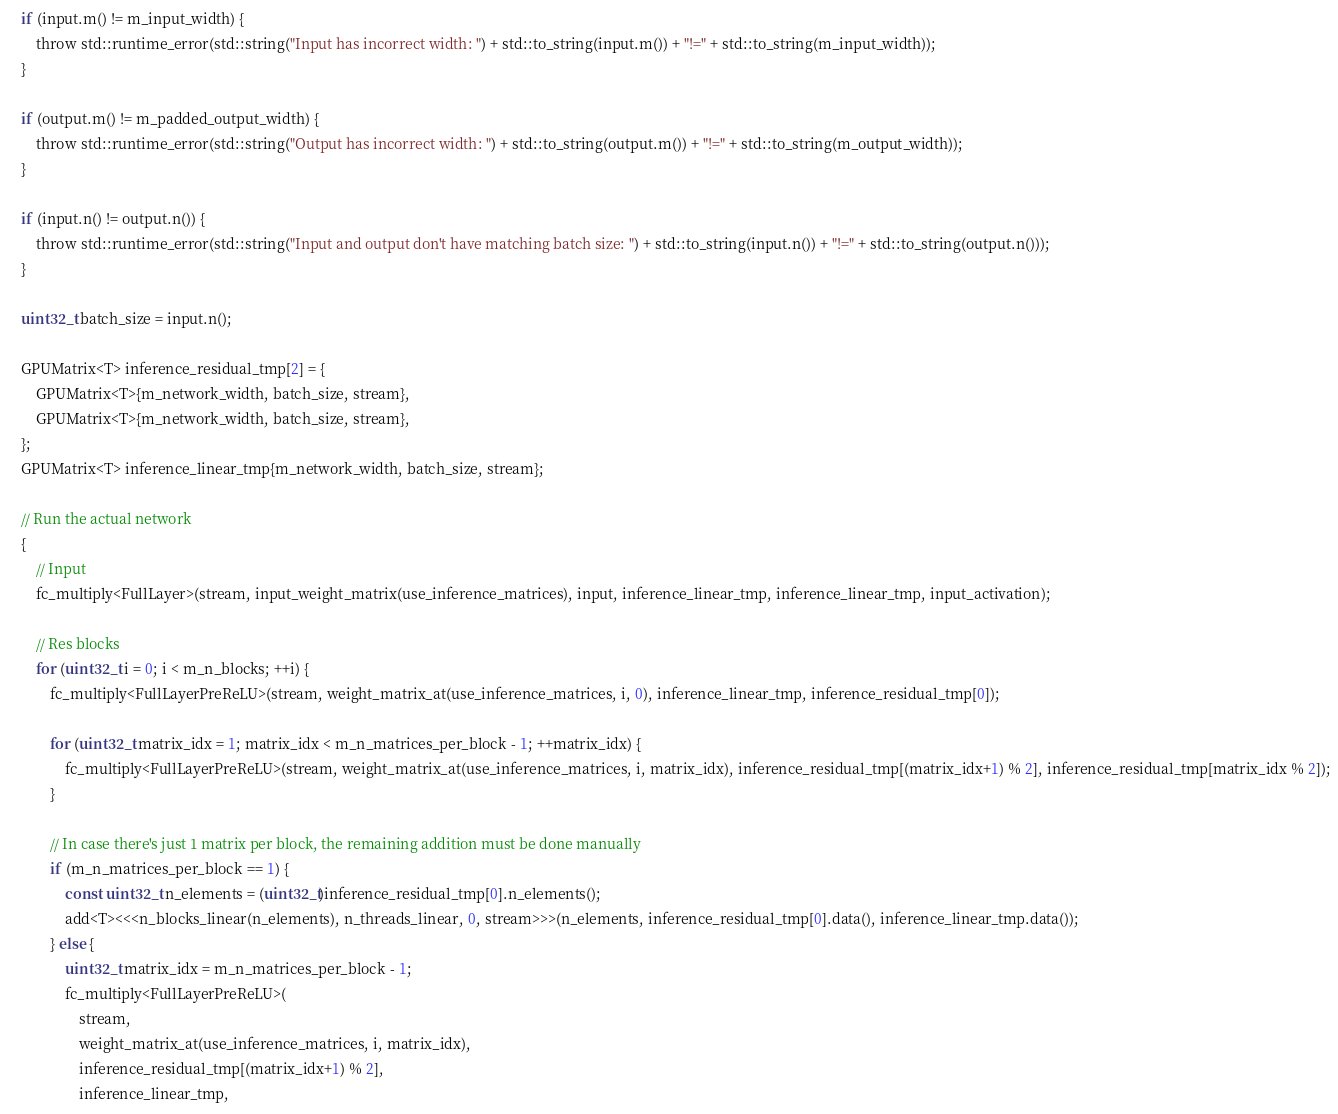Convert code to text. <code><loc_0><loc_0><loc_500><loc_500><_Cuda_>	if (input.m() != m_input_width) {
		throw std::runtime_error(std::string("Input has incorrect width: ") + std::to_string(input.m()) + "!=" + std::to_string(m_input_width));
	}

	if (output.m() != m_padded_output_width) {
		throw std::runtime_error(std::string("Output has incorrect width: ") + std::to_string(output.m()) + "!=" + std::to_string(m_output_width));
	}

	if (input.n() != output.n()) {
		throw std::runtime_error(std::string("Input and output don't have matching batch size: ") + std::to_string(input.n()) + "!=" + std::to_string(output.n()));
	}

	uint32_t batch_size = input.n();

	GPUMatrix<T> inference_residual_tmp[2] = {
		GPUMatrix<T>{m_network_width, batch_size, stream},
		GPUMatrix<T>{m_network_width, batch_size, stream},
	};
	GPUMatrix<T> inference_linear_tmp{m_network_width, batch_size, stream};

	// Run the actual network
	{
		// Input
		fc_multiply<FullLayer>(stream, input_weight_matrix(use_inference_matrices), input, inference_linear_tmp, inference_linear_tmp, input_activation);

		// Res blocks
		for (uint32_t i = 0; i < m_n_blocks; ++i) {
			fc_multiply<FullLayerPreReLU>(stream, weight_matrix_at(use_inference_matrices, i, 0), inference_linear_tmp, inference_residual_tmp[0]);

			for (uint32_t matrix_idx = 1; matrix_idx < m_n_matrices_per_block - 1; ++matrix_idx) {
				fc_multiply<FullLayerPreReLU>(stream, weight_matrix_at(use_inference_matrices, i, matrix_idx), inference_residual_tmp[(matrix_idx+1) % 2], inference_residual_tmp[matrix_idx % 2]);
			}

			// In case there's just 1 matrix per block, the remaining addition must be done manually
			if (m_n_matrices_per_block == 1) {
				const uint32_t n_elements = (uint32_t)inference_residual_tmp[0].n_elements();
				add<T><<<n_blocks_linear(n_elements), n_threads_linear, 0, stream>>>(n_elements, inference_residual_tmp[0].data(), inference_linear_tmp.data());
			} else {
				uint32_t matrix_idx = m_n_matrices_per_block - 1;
				fc_multiply<FullLayerPreReLU>(
					stream,
					weight_matrix_at(use_inference_matrices, i, matrix_idx),
					inference_residual_tmp[(matrix_idx+1) % 2],
					inference_linear_tmp,</code> 